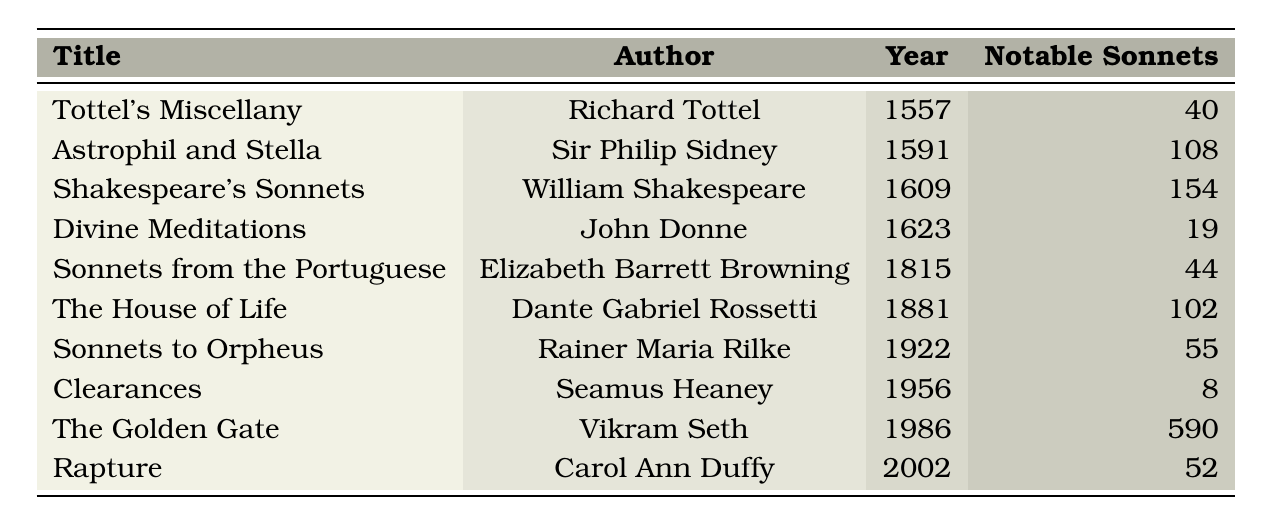What is the title of the sonnet collection published in 1609? The table lists the publication years along with their corresponding titles, and the entry for the year 1609 shows "Shakespeare's Sonnets."
Answer: Shakespeare's Sonnets Who is the author of "Sonnets from the Portuguese"? By looking at the table, the entry for "Sonnets from the Portuguese" indicates that Elizabeth Barrett Browning is the author.
Answer: Elizabeth Barrett Browning How many notable sonnets are in "The Golden Gate"? The entry for "The Golden Gate" shows that it contains 590 notable sonnets.
Answer: 590 Which collection published in 1815 has more notable sonnets than John Donne's "Divine Meditations"? Comparing the notable sonnets: "Sonnets from the Portuguese" has 44 and "Divine Meditations" has 19. Since 44 > 19, "Sonnets from the Portuguese" qualifies.
Answer: Sonnets from the Portuguese What is the difference in the number of notable sonnets between "Astrophil and Stella" and "Clearances"? To find this, subtract the number of notable sonnets in "Clearances" (8) from "Astrophil and Stella" (108). So, 108 - 8 = 100.
Answer: 100 Which author has the highest number of notable sonnets in their collection? Checking the notable sonnets counts, "The Golden Gate" by Vikram Seth has 590, the highest in the table.
Answer: Vikram Seth Is it true that John Donne published more notable sonnets than Elizabeth Barrett Browning? John Donne's "Divine Meditations" has 19 notable sonnets, while Elizabeth Barrett Browning's "Sonnets from the Portuguese" has 44. Thus, it is not true.
Answer: No What is the average number of notable sonnets across all collections listed? Total notable sonnets = 40 + 108 + 154 + 19 + 44 + 102 + 55 + 8 + 590 + 52 = 1,122. There are 10 collections, so the average is 1,122 / 10 = 112.2.
Answer: 112.2 In what year was the collection with the second highest notable sonnets released? Looking at the table, "Astrophil and Stella" has the second highest notable sonnets (108), published in 1591.
Answer: 1591 How many collections were published in the 20th century? The table shows "Sonnets to Orpheus," "Clearances," and "The Golden Gate," which totals three collections published in the 20th century (1922, 1956, 1986).
Answer: 3 